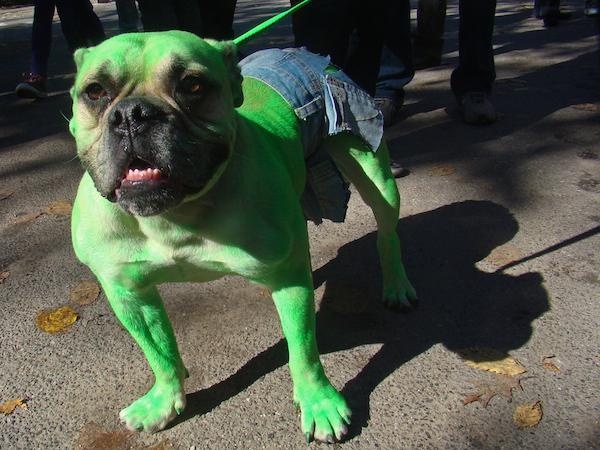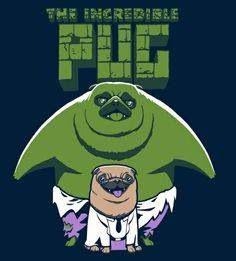The first image is the image on the left, the second image is the image on the right. For the images shown, is this caption "A dog is showing its tongue in the right image." true? Answer yes or no. No. The first image is the image on the left, the second image is the image on the right. For the images displayed, is the sentence "One image shows a pug with green-dyed fur wearing blue shorts and gazing toward the camera." factually correct? Answer yes or no. Yes. 